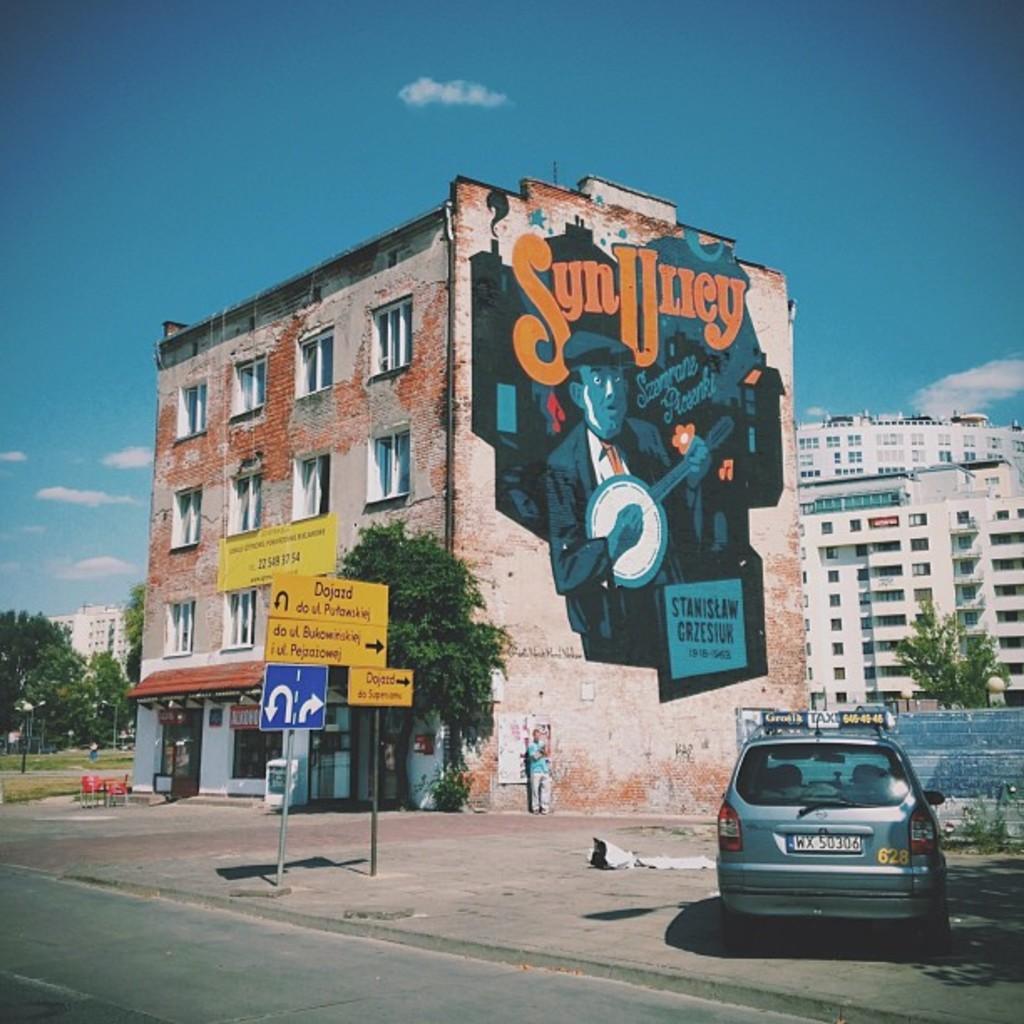Can you describe this image briefly? In the picture there is a building and below the building there are two stores and there is some painting of a person on the building wall, on the right side there are some boards and beside the boards there is a car parked on the footpath, behind the building there are many other towers and also few trees. 